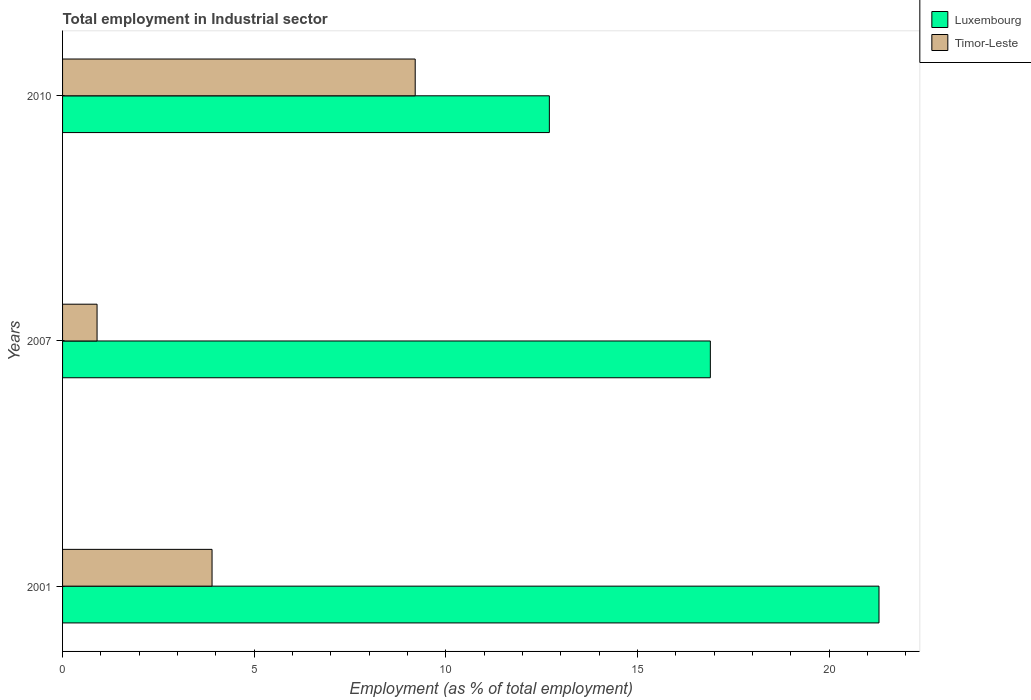How many different coloured bars are there?
Your answer should be compact. 2. Are the number of bars per tick equal to the number of legend labels?
Offer a terse response. Yes. How many bars are there on the 3rd tick from the top?
Give a very brief answer. 2. How many bars are there on the 1st tick from the bottom?
Ensure brevity in your answer.  2. What is the label of the 2nd group of bars from the top?
Keep it short and to the point. 2007. What is the employment in industrial sector in Timor-Leste in 2001?
Your answer should be compact. 3.9. Across all years, what is the maximum employment in industrial sector in Timor-Leste?
Your answer should be compact. 9.2. Across all years, what is the minimum employment in industrial sector in Luxembourg?
Make the answer very short. 12.7. In which year was the employment in industrial sector in Timor-Leste minimum?
Keep it short and to the point. 2007. What is the total employment in industrial sector in Luxembourg in the graph?
Make the answer very short. 50.9. What is the difference between the employment in industrial sector in Timor-Leste in 2001 and that in 2010?
Provide a succinct answer. -5.3. What is the difference between the employment in industrial sector in Timor-Leste in 2007 and the employment in industrial sector in Luxembourg in 2001?
Keep it short and to the point. -20.4. What is the average employment in industrial sector in Luxembourg per year?
Give a very brief answer. 16.97. In the year 2001, what is the difference between the employment in industrial sector in Timor-Leste and employment in industrial sector in Luxembourg?
Give a very brief answer. -17.4. In how many years, is the employment in industrial sector in Timor-Leste greater than 21 %?
Keep it short and to the point. 0. What is the ratio of the employment in industrial sector in Luxembourg in 2007 to that in 2010?
Keep it short and to the point. 1.33. Is the employment in industrial sector in Timor-Leste in 2001 less than that in 2007?
Provide a short and direct response. No. What is the difference between the highest and the second highest employment in industrial sector in Luxembourg?
Give a very brief answer. 4.4. What is the difference between the highest and the lowest employment in industrial sector in Timor-Leste?
Offer a very short reply. 8.3. In how many years, is the employment in industrial sector in Luxembourg greater than the average employment in industrial sector in Luxembourg taken over all years?
Your answer should be very brief. 1. What does the 1st bar from the top in 2007 represents?
Your answer should be very brief. Timor-Leste. What does the 2nd bar from the bottom in 2010 represents?
Keep it short and to the point. Timor-Leste. What is the difference between two consecutive major ticks on the X-axis?
Your response must be concise. 5. Does the graph contain any zero values?
Your answer should be very brief. No. Does the graph contain grids?
Your answer should be compact. No. Where does the legend appear in the graph?
Keep it short and to the point. Top right. What is the title of the graph?
Your answer should be very brief. Total employment in Industrial sector. What is the label or title of the X-axis?
Provide a succinct answer. Employment (as % of total employment). What is the Employment (as % of total employment) in Luxembourg in 2001?
Make the answer very short. 21.3. What is the Employment (as % of total employment) of Timor-Leste in 2001?
Keep it short and to the point. 3.9. What is the Employment (as % of total employment) of Luxembourg in 2007?
Your answer should be very brief. 16.9. What is the Employment (as % of total employment) in Timor-Leste in 2007?
Offer a very short reply. 0.9. What is the Employment (as % of total employment) of Luxembourg in 2010?
Provide a short and direct response. 12.7. What is the Employment (as % of total employment) in Timor-Leste in 2010?
Give a very brief answer. 9.2. Across all years, what is the maximum Employment (as % of total employment) in Luxembourg?
Offer a very short reply. 21.3. Across all years, what is the maximum Employment (as % of total employment) of Timor-Leste?
Provide a succinct answer. 9.2. Across all years, what is the minimum Employment (as % of total employment) in Luxembourg?
Your answer should be very brief. 12.7. Across all years, what is the minimum Employment (as % of total employment) of Timor-Leste?
Your response must be concise. 0.9. What is the total Employment (as % of total employment) of Luxembourg in the graph?
Keep it short and to the point. 50.9. What is the difference between the Employment (as % of total employment) in Luxembourg in 2001 and that in 2007?
Ensure brevity in your answer.  4.4. What is the difference between the Employment (as % of total employment) of Timor-Leste in 2001 and that in 2007?
Offer a very short reply. 3. What is the difference between the Employment (as % of total employment) in Luxembourg in 2001 and that in 2010?
Offer a very short reply. 8.6. What is the difference between the Employment (as % of total employment) in Timor-Leste in 2001 and that in 2010?
Your response must be concise. -5.3. What is the difference between the Employment (as % of total employment) of Timor-Leste in 2007 and that in 2010?
Your answer should be compact. -8.3. What is the difference between the Employment (as % of total employment) of Luxembourg in 2001 and the Employment (as % of total employment) of Timor-Leste in 2007?
Offer a terse response. 20.4. What is the difference between the Employment (as % of total employment) in Luxembourg in 2001 and the Employment (as % of total employment) in Timor-Leste in 2010?
Keep it short and to the point. 12.1. What is the difference between the Employment (as % of total employment) of Luxembourg in 2007 and the Employment (as % of total employment) of Timor-Leste in 2010?
Make the answer very short. 7.7. What is the average Employment (as % of total employment) of Luxembourg per year?
Your answer should be very brief. 16.97. What is the average Employment (as % of total employment) of Timor-Leste per year?
Give a very brief answer. 4.67. In the year 2001, what is the difference between the Employment (as % of total employment) of Luxembourg and Employment (as % of total employment) of Timor-Leste?
Make the answer very short. 17.4. What is the ratio of the Employment (as % of total employment) in Luxembourg in 2001 to that in 2007?
Your response must be concise. 1.26. What is the ratio of the Employment (as % of total employment) of Timor-Leste in 2001 to that in 2007?
Give a very brief answer. 4.33. What is the ratio of the Employment (as % of total employment) in Luxembourg in 2001 to that in 2010?
Your answer should be very brief. 1.68. What is the ratio of the Employment (as % of total employment) of Timor-Leste in 2001 to that in 2010?
Give a very brief answer. 0.42. What is the ratio of the Employment (as % of total employment) of Luxembourg in 2007 to that in 2010?
Ensure brevity in your answer.  1.33. What is the ratio of the Employment (as % of total employment) of Timor-Leste in 2007 to that in 2010?
Offer a terse response. 0.1. What is the difference between the highest and the lowest Employment (as % of total employment) of Timor-Leste?
Give a very brief answer. 8.3. 